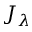Convert formula to latex. <formula><loc_0><loc_0><loc_500><loc_500>J _ { \lambda }</formula> 